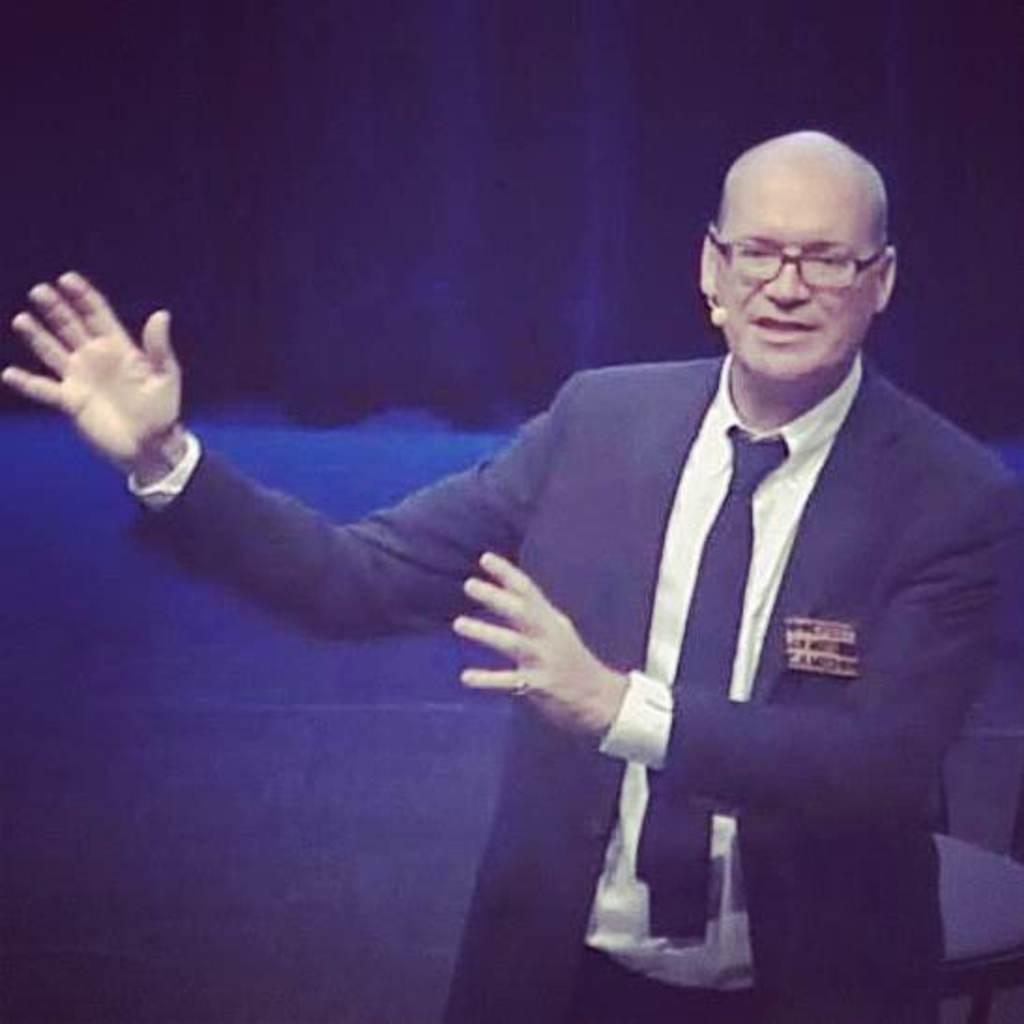What is the main subject of the picture? The main subject of the picture is a man. What is the man wearing in the picture? The man is wearing a blazer and spectacles in the picture. What is the man doing in the picture? The man is explaining something in the picture. What color is the background of the man in the picture? The background of the man is in blue color. What type of brush is the man using to create his art in the image? There is no brush or art present in the image; the man is explaining something while wearing a blazer and spectacles. What color are the man's trousers in the image? The provided facts do not mention the color of the man's trousers, so we cannot definitively answer that question. 